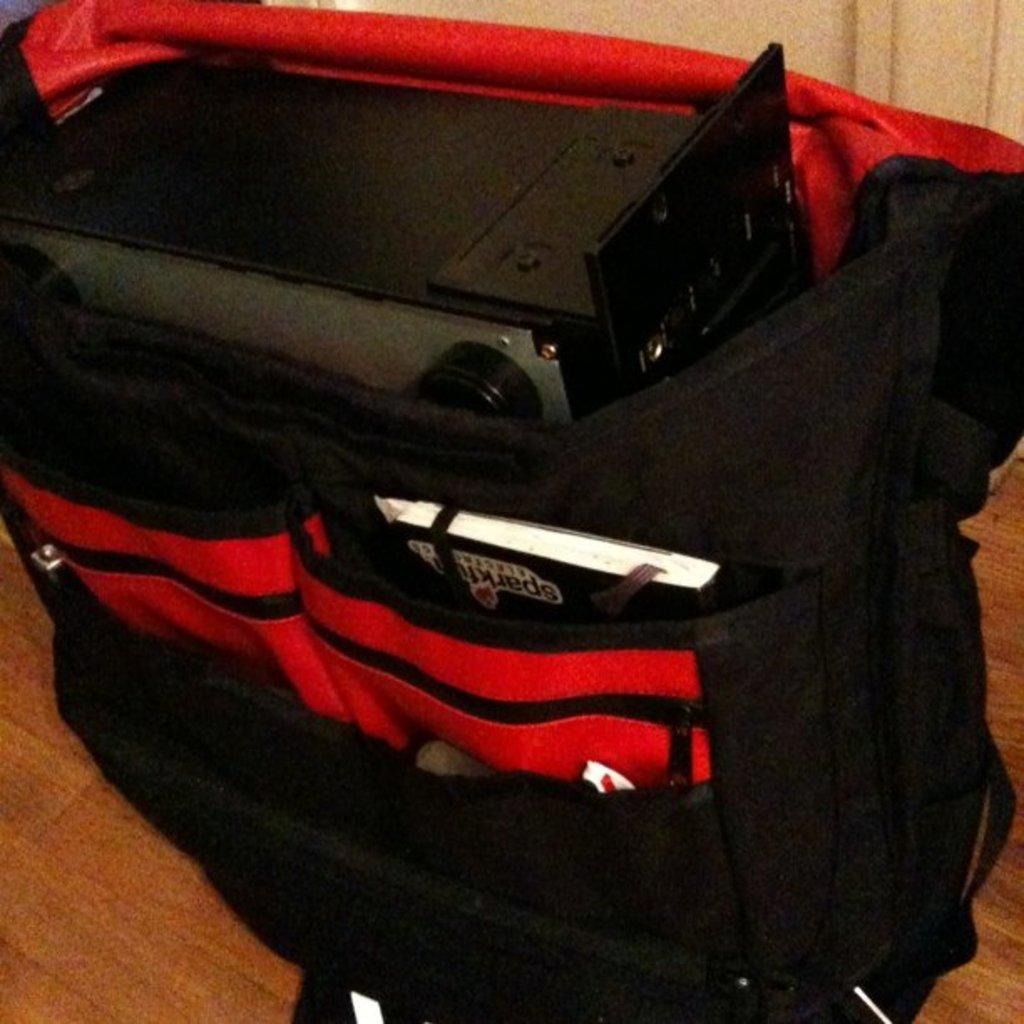In one or two sentences, can you explain what this image depicts? In this picture we can see an object in the bag. 